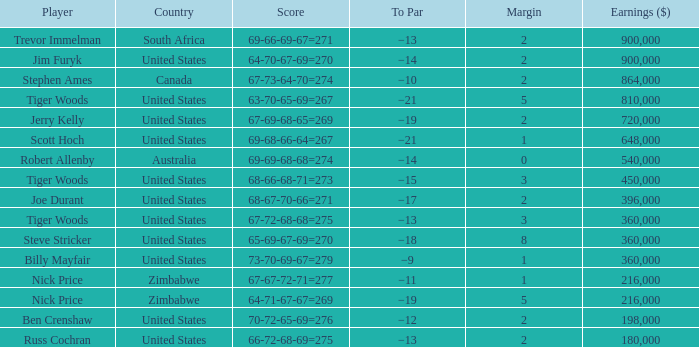Which margin has a state of united states, and a score of 63-70-65-69=267? 5.0. 